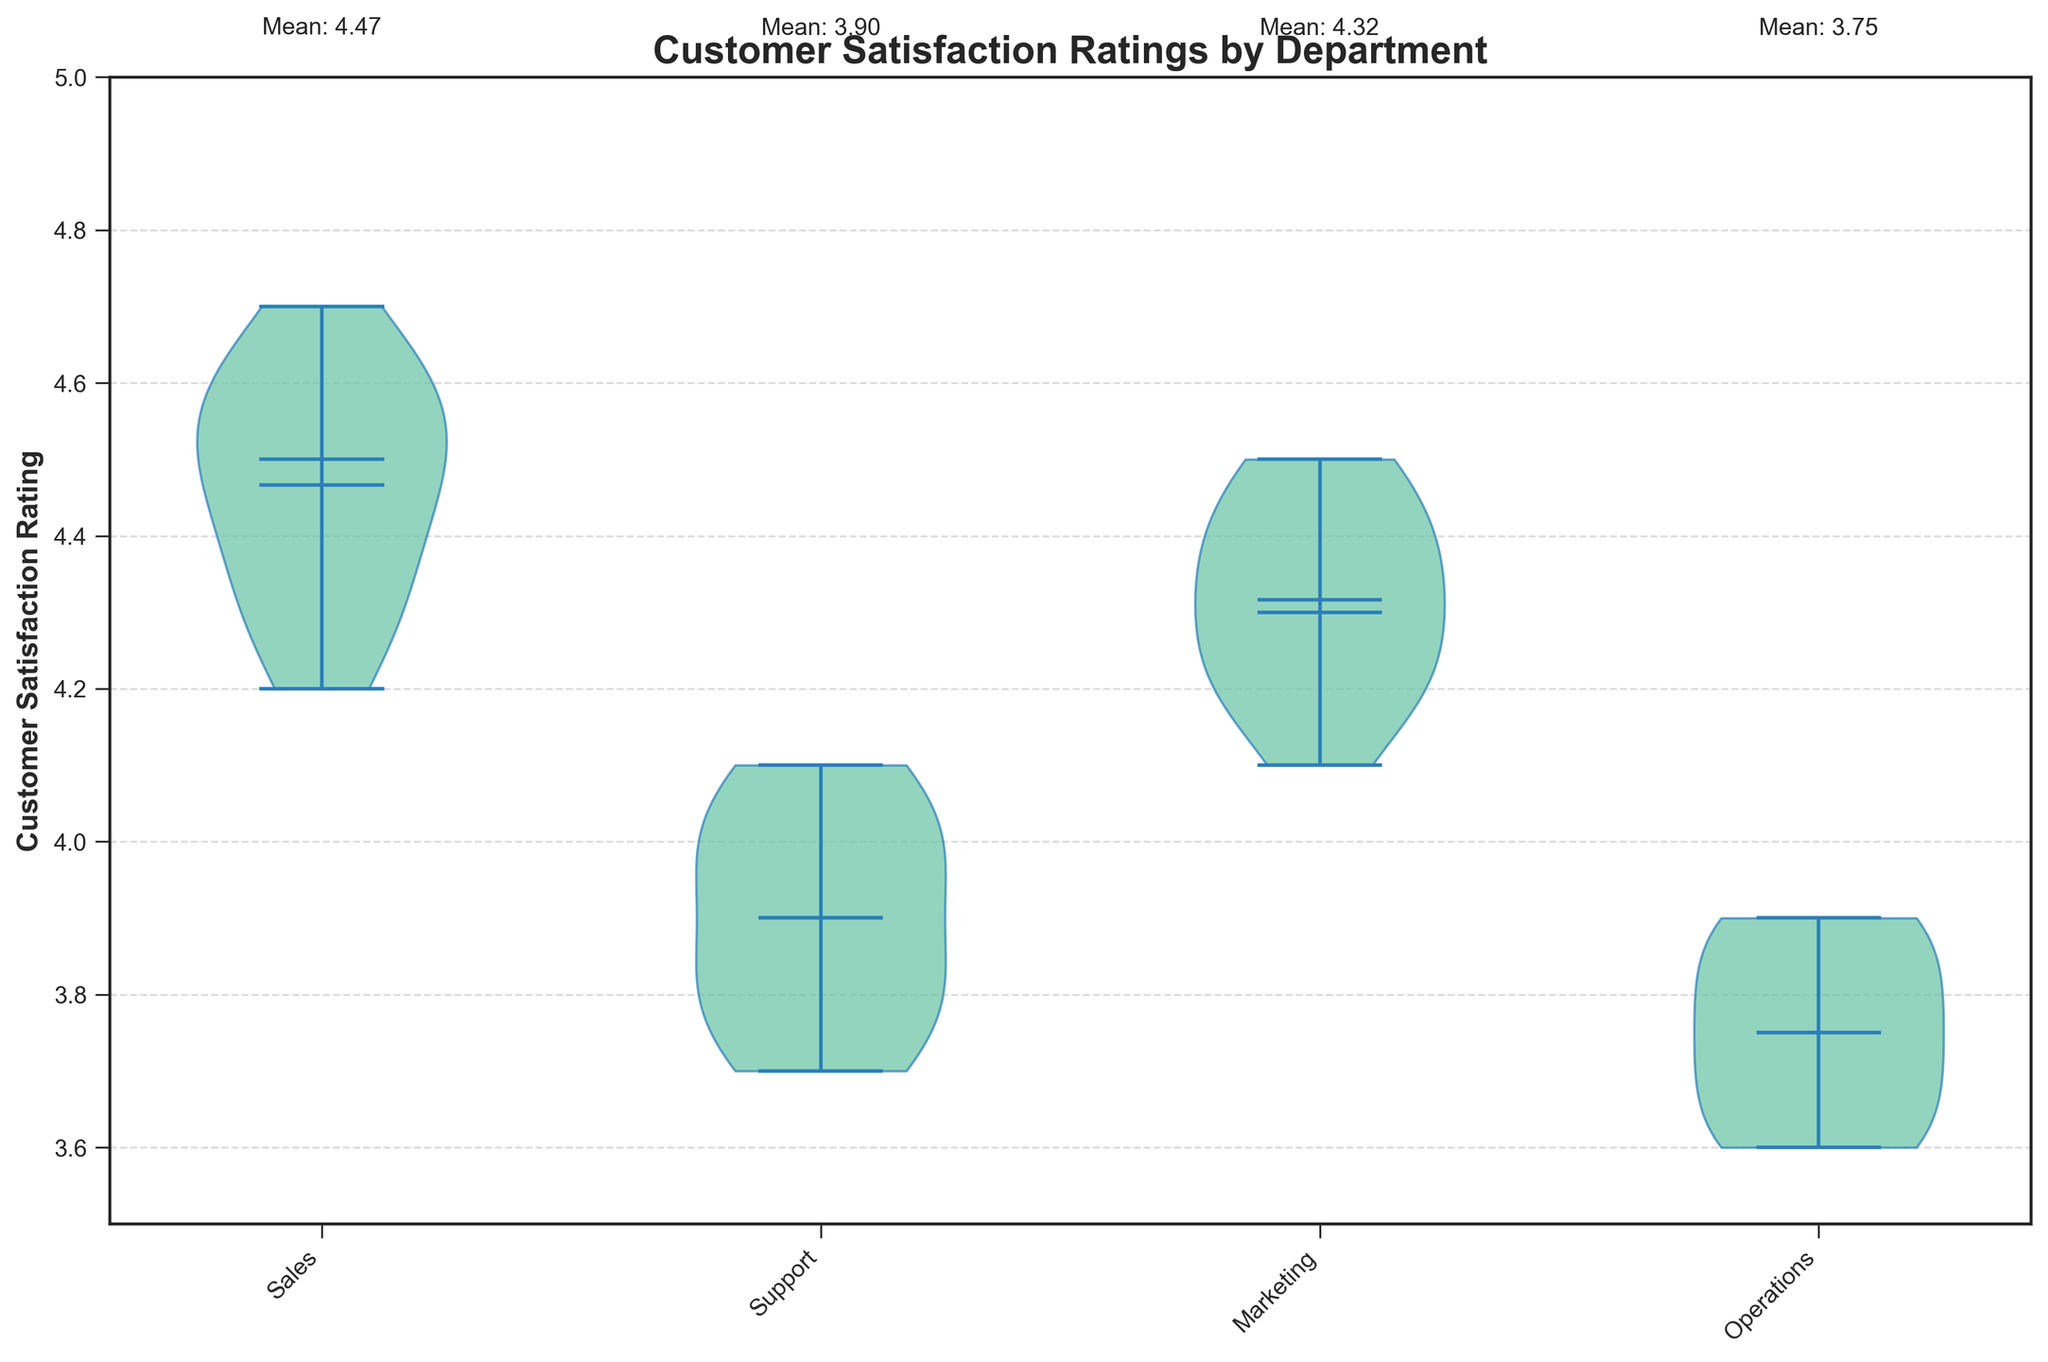What is the title of the figure? The title of the figure is usually found at the top of the chart. In this case, it describes the content and context of the chart.
Answer: Customer Satisfaction Ratings by Department Which department has the highest mean customer satisfaction rating? The mean customer satisfaction rating for each department is shown by a horizontal line within the violin plot and also labeled above the department's plot. By comparing these means, we can identify the department with the highest mean.
Answer: Sales What is the mean customer satisfaction rating for the Marketing department? Above the violin plot for each department, the mean customer satisfaction rating is labeled. Locate the label above the plot for the Marketing department to find the answer.
Answer: 4.31 Which department has the narrowest range of customer satisfaction ratings? The range of customer satisfaction ratings can be seen by the width of the violin plots. The narrowest plot indicates the smallest range of data. By comparing the widths of all plots, we can identify the narrowest one.
Answer: Marketing Which department has the widest range of customer satisfaction ratings? Similar to finding the narrowest range, the widest range is indicated by the widest violin plot. Comparing the width of each plot allows us to determine the department with the widest range.
Answer: Support What is the median customer satisfaction rating for Operations? The median is represented by the horizontal line within each violin plot. Locate this line in the Operations department’s plot to find the median rating.
Answer: 3.75 How does the median customer satisfaction rating of Sales compare to that of Support? To compare the medians, locate the horizontal line within the violin plots for both Sales and Support. The Sales department's violin plot has a higher median line compared to Support's.
Answer: Sales has a higher median Are there departments with identical median customer satisfaction ratings? Check the medians (horizontal lines within the plots) across all departments to see if any are at the same level.
Answer: Yes, Operations and Support Which department consistently scored below 4.0 in customer satisfaction ratings? By inspecting the violin plots, look for any department plots that do not extend above the 4.0 mark at any point.
Answer: Operations 